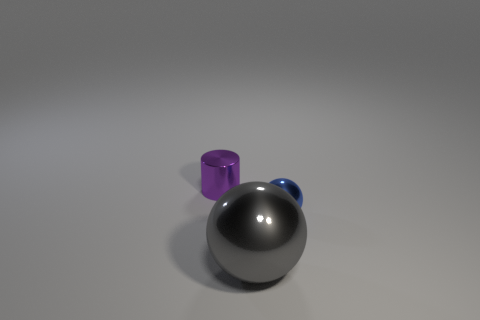Add 3 tiny metallic objects. How many objects exist? 6 Subtract all spheres. How many objects are left? 1 Subtract all blue balls. Subtract all large yellow metal balls. How many objects are left? 2 Add 3 shiny balls. How many shiny balls are left? 5 Add 3 tiny rubber spheres. How many tiny rubber spheres exist? 3 Subtract 1 blue balls. How many objects are left? 2 